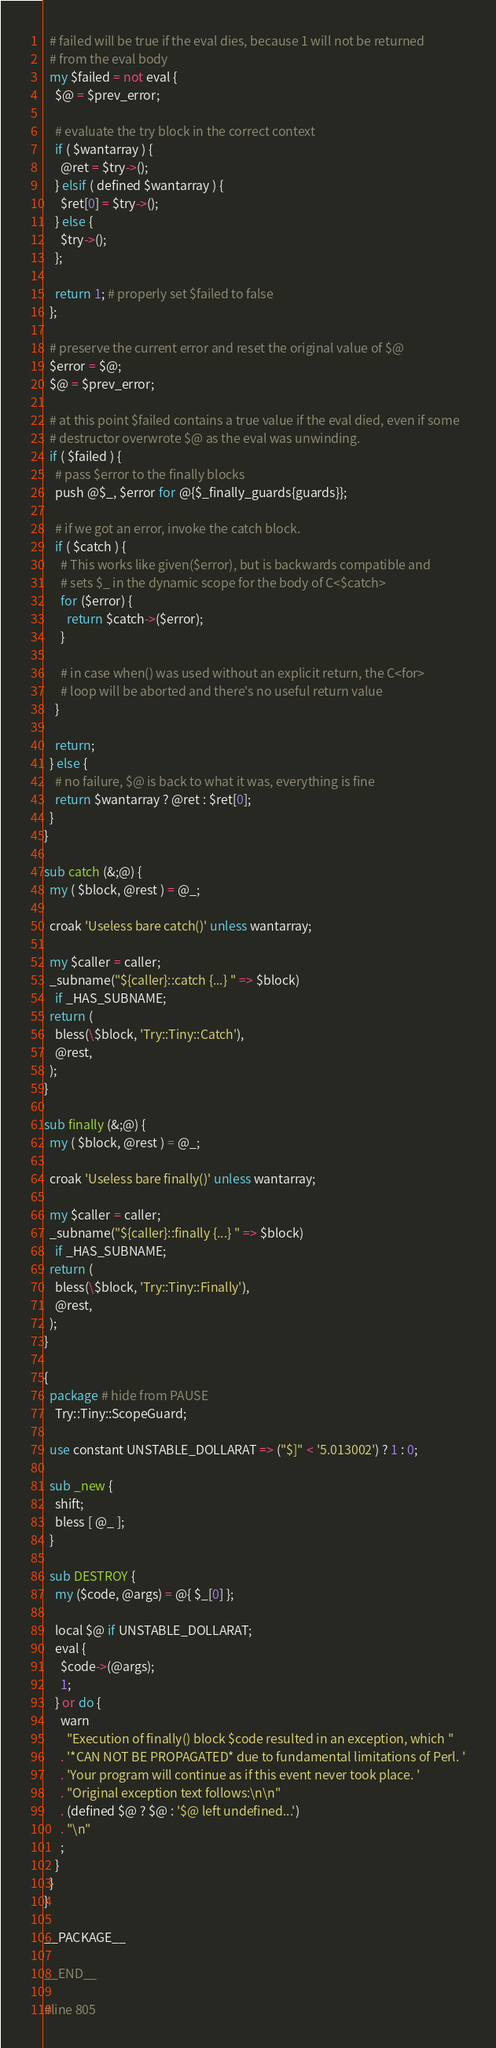<code> <loc_0><loc_0><loc_500><loc_500><_Perl_>  # failed will be true if the eval dies, because 1 will not be returned
  # from the eval body
  my $failed = not eval {
    $@ = $prev_error;

    # evaluate the try block in the correct context
    if ( $wantarray ) {
      @ret = $try->();
    } elsif ( defined $wantarray ) {
      $ret[0] = $try->();
    } else {
      $try->();
    };

    return 1; # properly set $failed to false
  };

  # preserve the current error and reset the original value of $@
  $error = $@;
  $@ = $prev_error;

  # at this point $failed contains a true value if the eval died, even if some
  # destructor overwrote $@ as the eval was unwinding.
  if ( $failed ) {
    # pass $error to the finally blocks
    push @$_, $error for @{$_finally_guards{guards}};

    # if we got an error, invoke the catch block.
    if ( $catch ) {
      # This works like given($error), but is backwards compatible and
      # sets $_ in the dynamic scope for the body of C<$catch>
      for ($error) {
        return $catch->($error);
      }

      # in case when() was used without an explicit return, the C<for>
      # loop will be aborted and there's no useful return value
    }

    return;
  } else {
    # no failure, $@ is back to what it was, everything is fine
    return $wantarray ? @ret : $ret[0];
  }
}

sub catch (&;@) {
  my ( $block, @rest ) = @_;

  croak 'Useless bare catch()' unless wantarray;

  my $caller = caller;
  _subname("${caller}::catch {...} " => $block)
    if _HAS_SUBNAME;
  return (
    bless(\$block, 'Try::Tiny::Catch'),
    @rest,
  );
}

sub finally (&;@) {
  my ( $block, @rest ) = @_;

  croak 'Useless bare finally()' unless wantarray;

  my $caller = caller;
  _subname("${caller}::finally {...} " => $block)
    if _HAS_SUBNAME;
  return (
    bless(\$block, 'Try::Tiny::Finally'),
    @rest,
  );
}

{
  package # hide from PAUSE
    Try::Tiny::ScopeGuard;

  use constant UNSTABLE_DOLLARAT => ("$]" < '5.013002') ? 1 : 0;

  sub _new {
    shift;
    bless [ @_ ];
  }

  sub DESTROY {
    my ($code, @args) = @{ $_[0] };

    local $@ if UNSTABLE_DOLLARAT;
    eval {
      $code->(@args);
      1;
    } or do {
      warn
        "Execution of finally() block $code resulted in an exception, which "
      . '*CAN NOT BE PROPAGATED* due to fundamental limitations of Perl. '
      . 'Your program will continue as if this event never took place. '
      . "Original exception text follows:\n\n"
      . (defined $@ ? $@ : '$@ left undefined...')
      . "\n"
      ;
    }
  }
}

__PACKAGE__

__END__

#line 805
</code> 